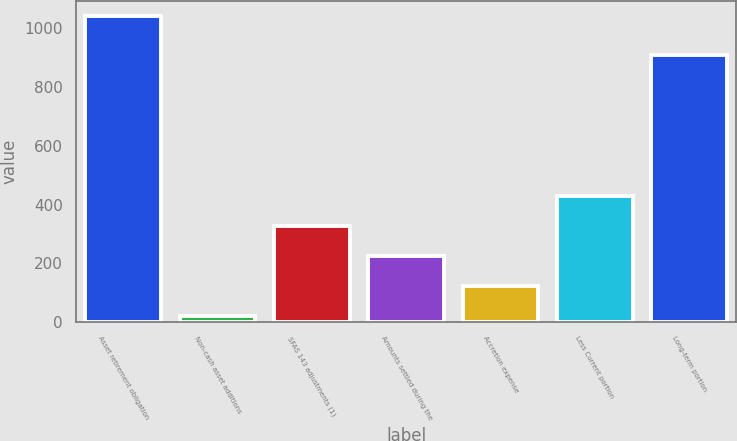<chart> <loc_0><loc_0><loc_500><loc_500><bar_chart><fcel>Asset retirement obligation<fcel>Non-cash asset additions<fcel>SFAS 143 adjustments (1)<fcel>Amounts settled during the<fcel>Accretion expense<fcel>Less Current portion<fcel>Long-term portion<nl><fcel>1040.6<fcel>20.5<fcel>326.53<fcel>224.52<fcel>122.51<fcel>428.54<fcel>910<nl></chart> 